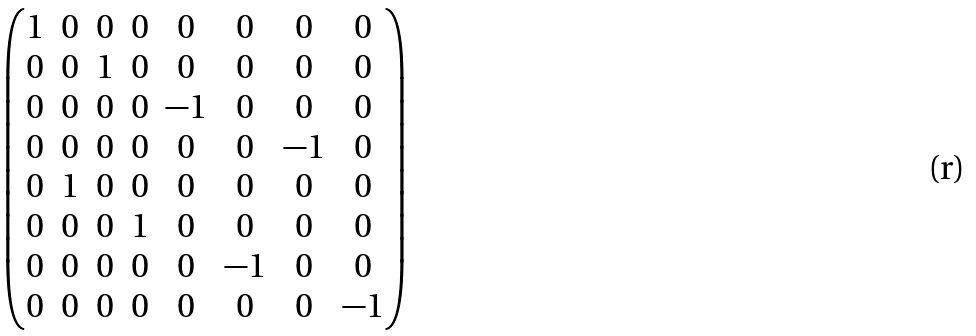Convert formula to latex. <formula><loc_0><loc_0><loc_500><loc_500>\begin{pmatrix} 1 & 0 & 0 & 0 & 0 & 0 & 0 & 0 \\ 0 & 0 & 1 & 0 & 0 & 0 & 0 & 0 \\ 0 & 0 & 0 & 0 & - 1 & 0 & 0 & 0 \\ 0 & 0 & 0 & 0 & 0 & 0 & - 1 & 0 \\ 0 & 1 & 0 & 0 & 0 & 0 & 0 & 0 \\ 0 & 0 & 0 & 1 & 0 & 0 & 0 & 0 \\ 0 & 0 & 0 & 0 & 0 & - 1 & 0 & 0 \\ 0 & 0 & 0 & 0 & 0 & 0 & 0 & - 1 \end{pmatrix}</formula> 